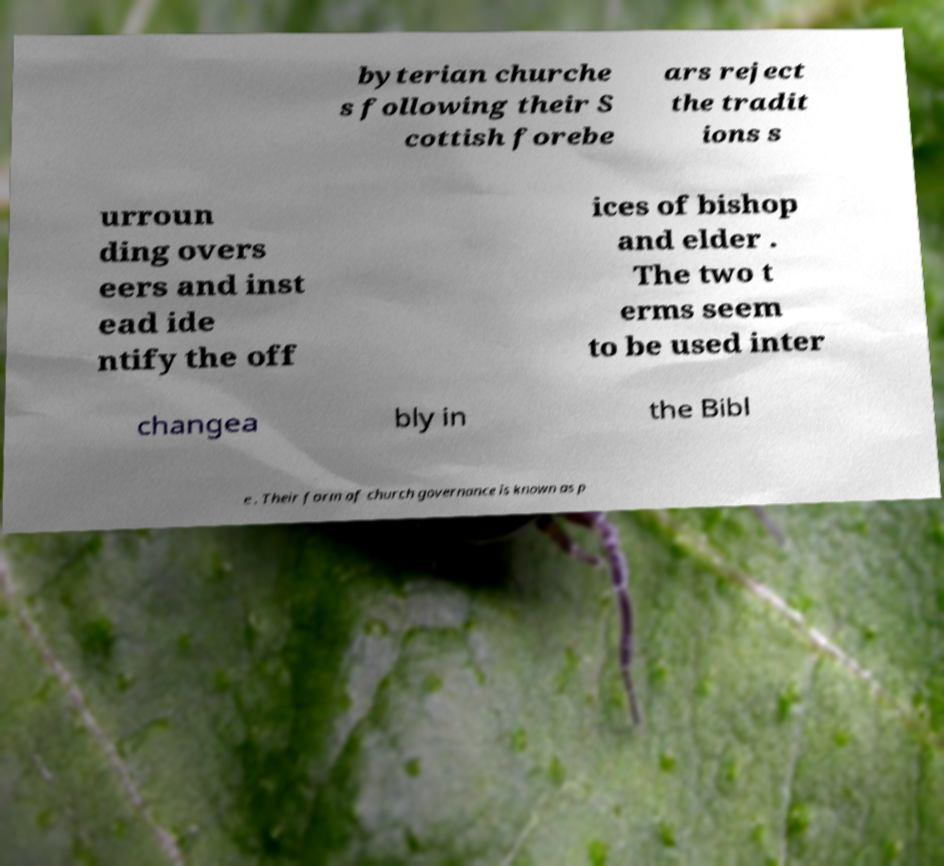There's text embedded in this image that I need extracted. Can you transcribe it verbatim? byterian churche s following their S cottish forebe ars reject the tradit ions s urroun ding overs eers and inst ead ide ntify the off ices of bishop and elder . The two t erms seem to be used inter changea bly in the Bibl e . Their form of church governance is known as p 